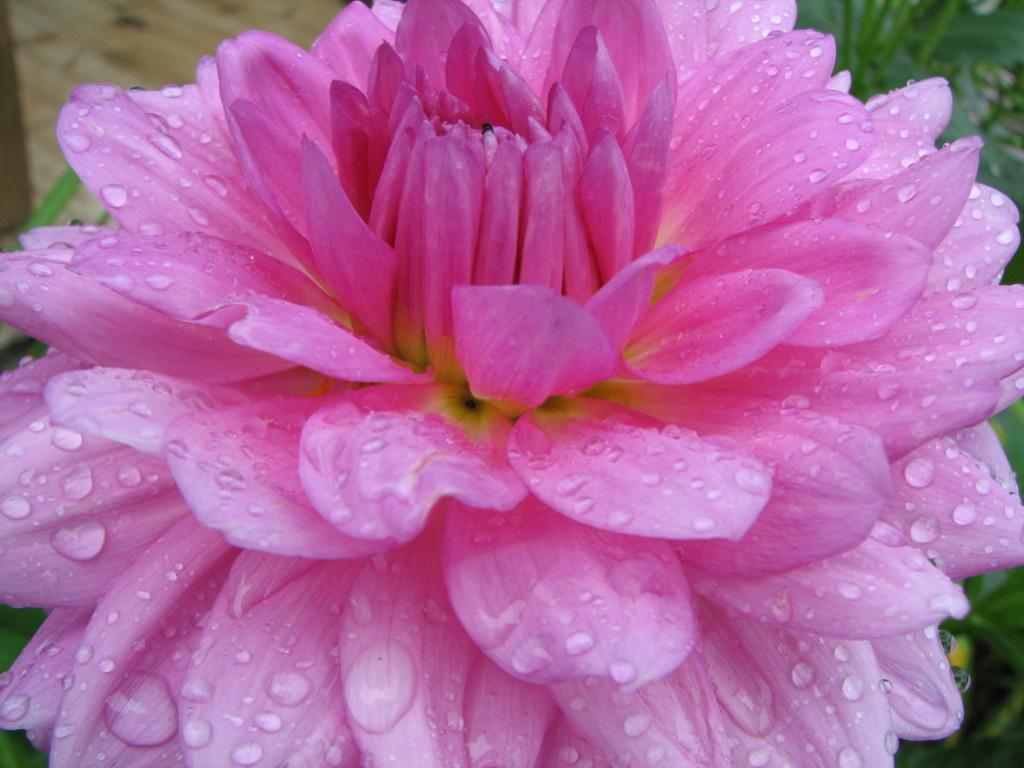What color is the flower in the image? The flower in the image is pink. What can be seen behind the flower in the image? There are blurred things behind the flower in the image. Where is the notebook used by the dinosaurs in the battle scene in the image? There is no notebook, dinosaurs, or battle scene present in the image; it only features a pink flower and blurred background elements. 